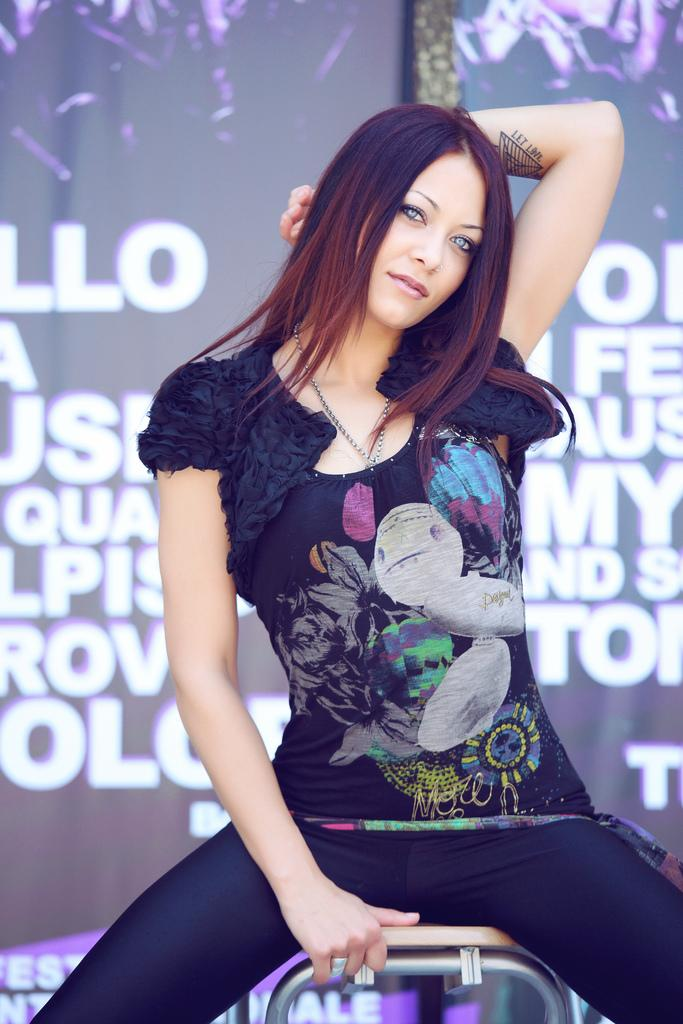Who is present in the image? There is a woman in the image. What is the woman doing in the image? The woman is sitting on a chair. What can be seen in the background of the image? There is some text visible in the background of the image. What type of quartz is present on the woman's lap in the image? There is no quartz present in the image; the woman is sitting on a chair with no visible objects on her lap. 